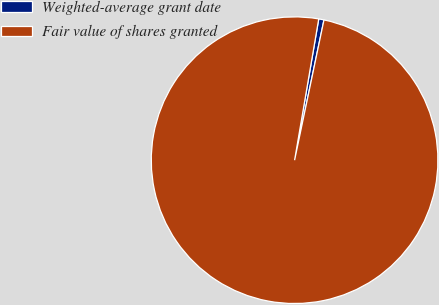Convert chart to OTSL. <chart><loc_0><loc_0><loc_500><loc_500><pie_chart><fcel>Weighted-average grant date<fcel>Fair value of shares granted<nl><fcel>0.59%<fcel>99.41%<nl></chart> 